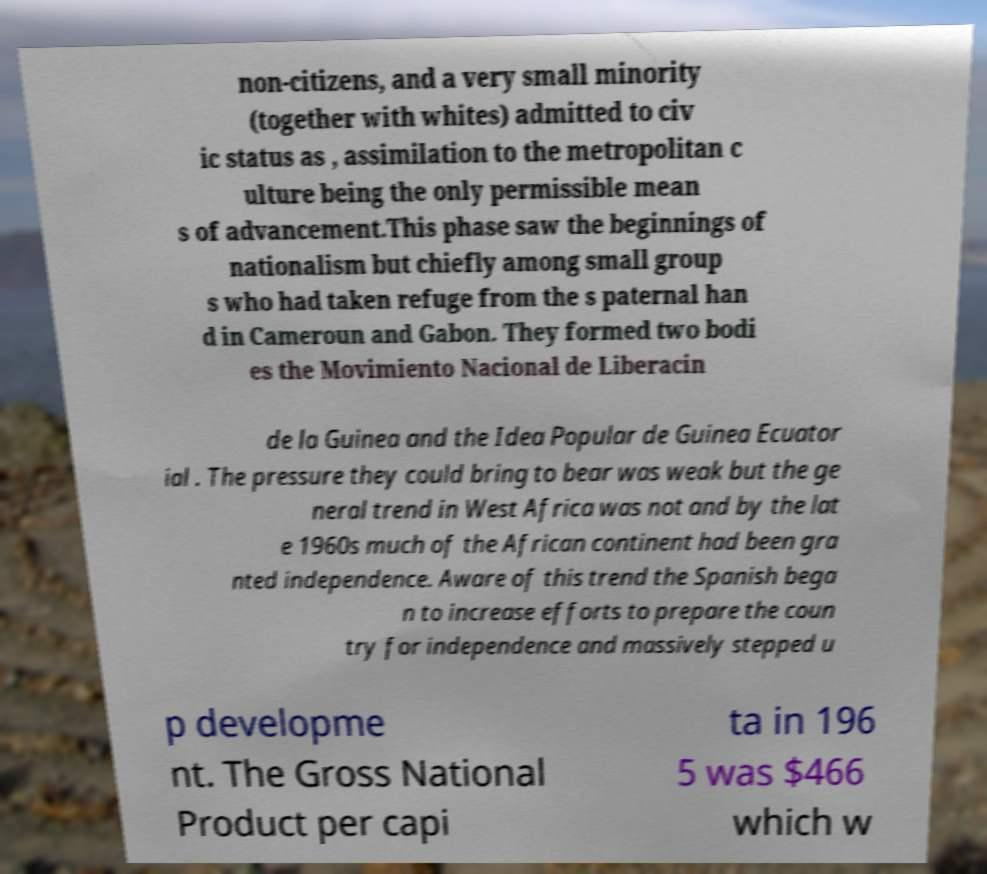For documentation purposes, I need the text within this image transcribed. Could you provide that? non-citizens, and a very small minority (together with whites) admitted to civ ic status as , assimilation to the metropolitan c ulture being the only permissible mean s of advancement.This phase saw the beginnings of nationalism but chiefly among small group s who had taken refuge from the s paternal han d in Cameroun and Gabon. They formed two bodi es the Movimiento Nacional de Liberacin de la Guinea and the Idea Popular de Guinea Ecuator ial . The pressure they could bring to bear was weak but the ge neral trend in West Africa was not and by the lat e 1960s much of the African continent had been gra nted independence. Aware of this trend the Spanish bega n to increase efforts to prepare the coun try for independence and massively stepped u p developme nt. The Gross National Product per capi ta in 196 5 was $466 which w 